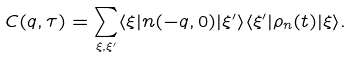<formula> <loc_0><loc_0><loc_500><loc_500>C ( q , \tau ) = \sum _ { \xi , \xi ^ { \prime } } \langle \xi | n ( - q , 0 ) | \xi ^ { \prime } \rangle \langle \xi ^ { \prime } | \rho _ { n } ( t ) | \xi \rangle .</formula> 